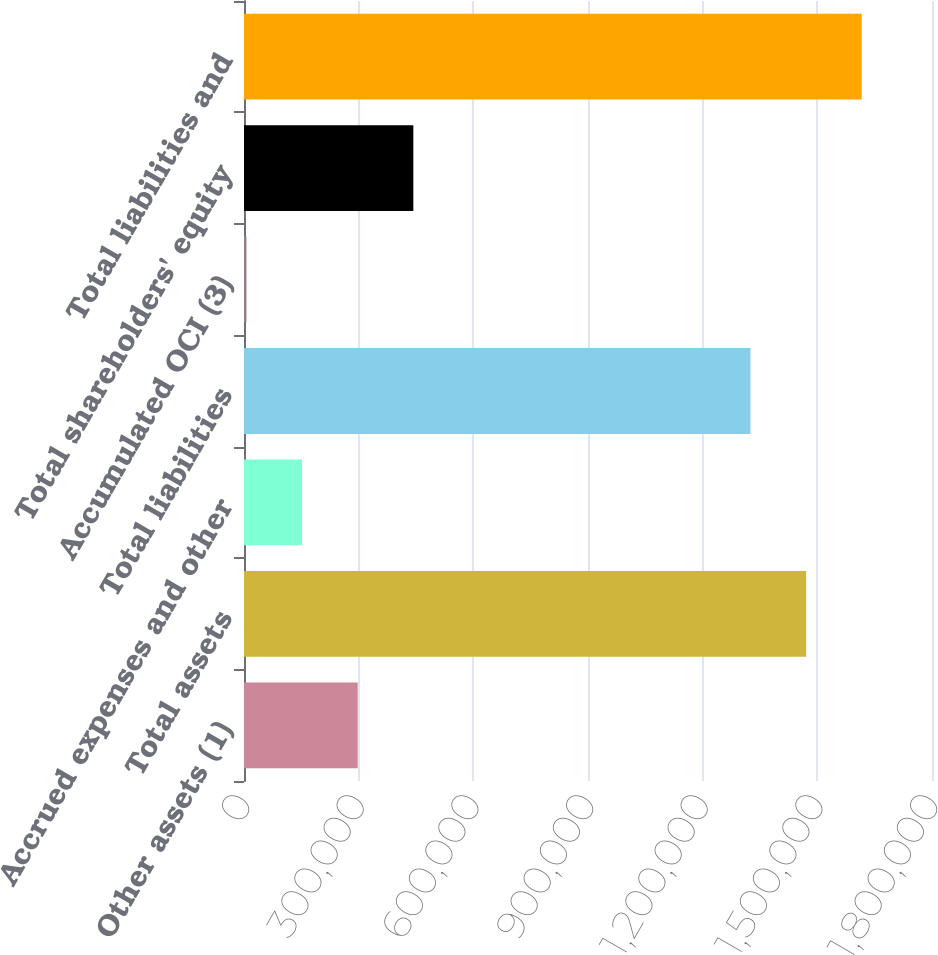Convert chart. <chart><loc_0><loc_0><loc_500><loc_500><bar_chart><fcel>Other assets (1)<fcel>Total assets<fcel>Accrued expenses and other<fcel>Total liabilities<fcel>Accumulated OCI (3)<fcel>Total shareholders' equity<fcel>Total liabilities and<nl><fcel>297463<fcel>1.47065e+06<fcel>151933<fcel>1.32512e+06<fcel>6403<fcel>442993<fcel>1.61618e+06<nl></chart> 